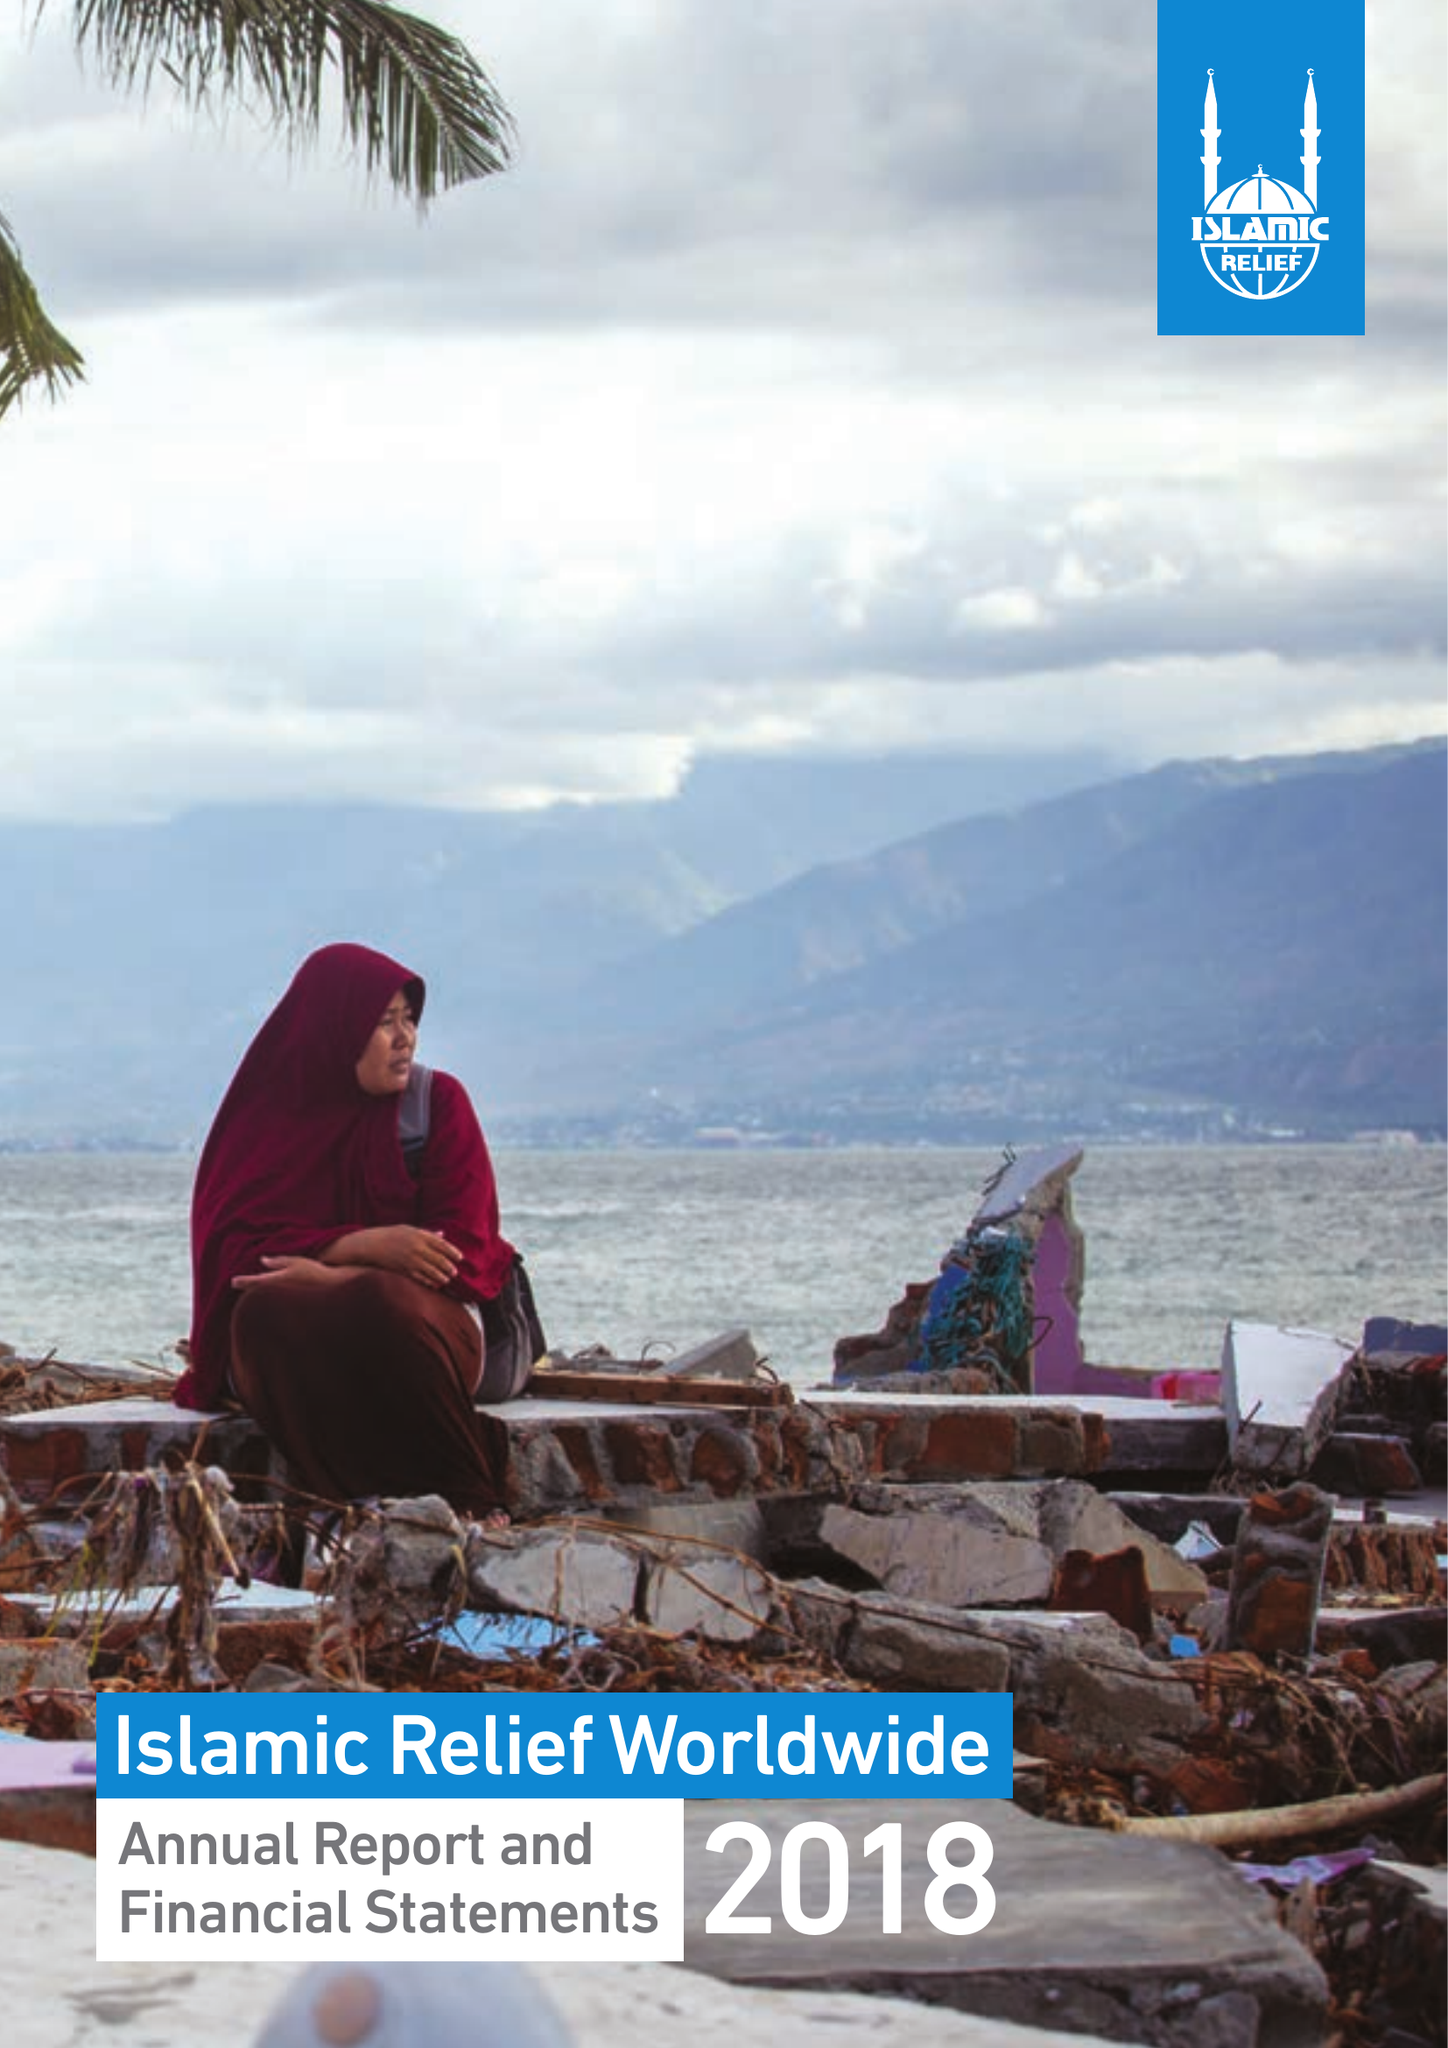What is the value for the address__post_town?
Answer the question using a single word or phrase. BIRMINGHAM 